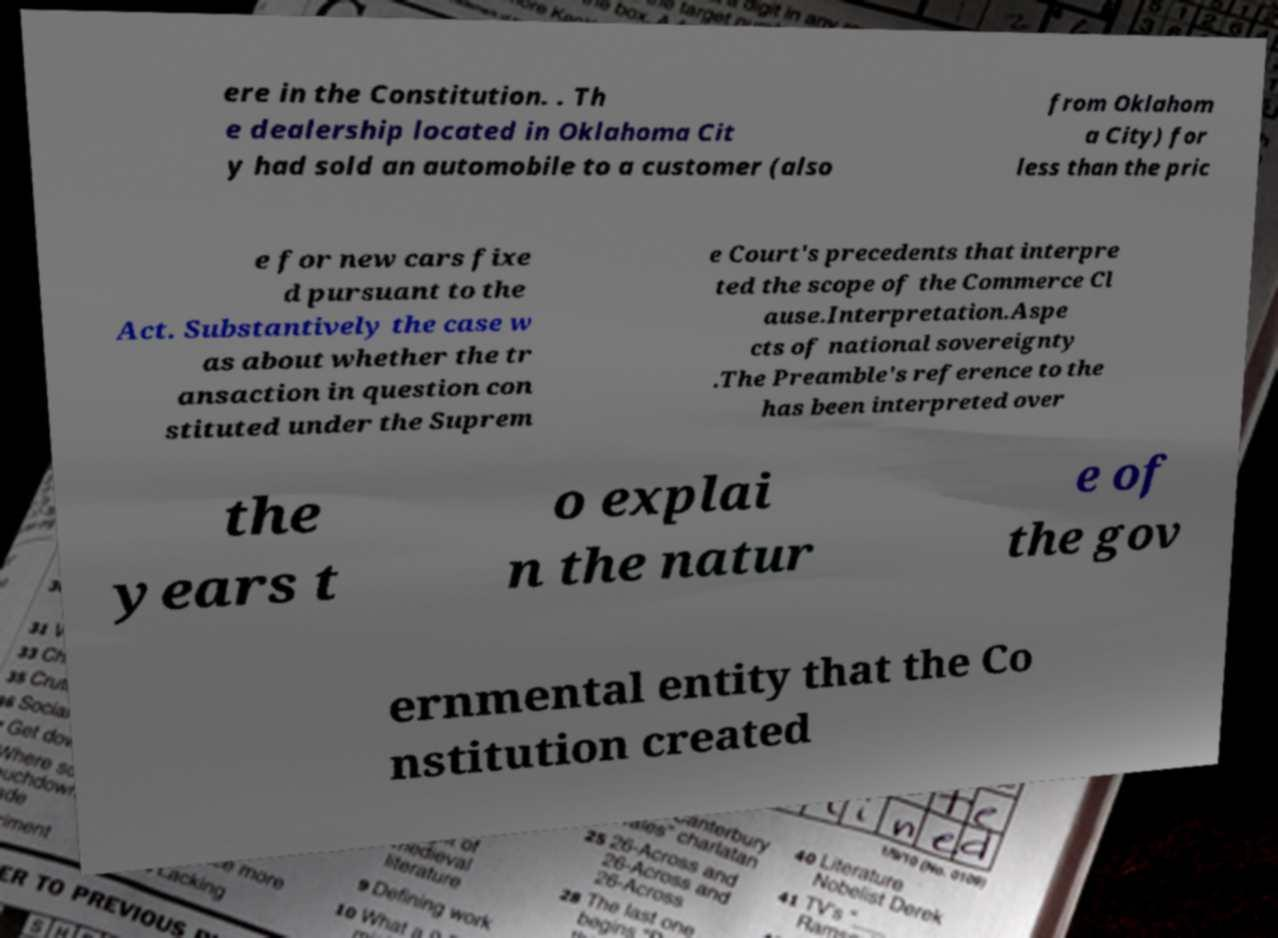For documentation purposes, I need the text within this image transcribed. Could you provide that? ere in the Constitution. . Th e dealership located in Oklahoma Cit y had sold an automobile to a customer (also from Oklahom a City) for less than the pric e for new cars fixe d pursuant to the Act. Substantively the case w as about whether the tr ansaction in question con stituted under the Suprem e Court's precedents that interpre ted the scope of the Commerce Cl ause.Interpretation.Aspe cts of national sovereignty .The Preamble's reference to the has been interpreted over the years t o explai n the natur e of the gov ernmental entity that the Co nstitution created 